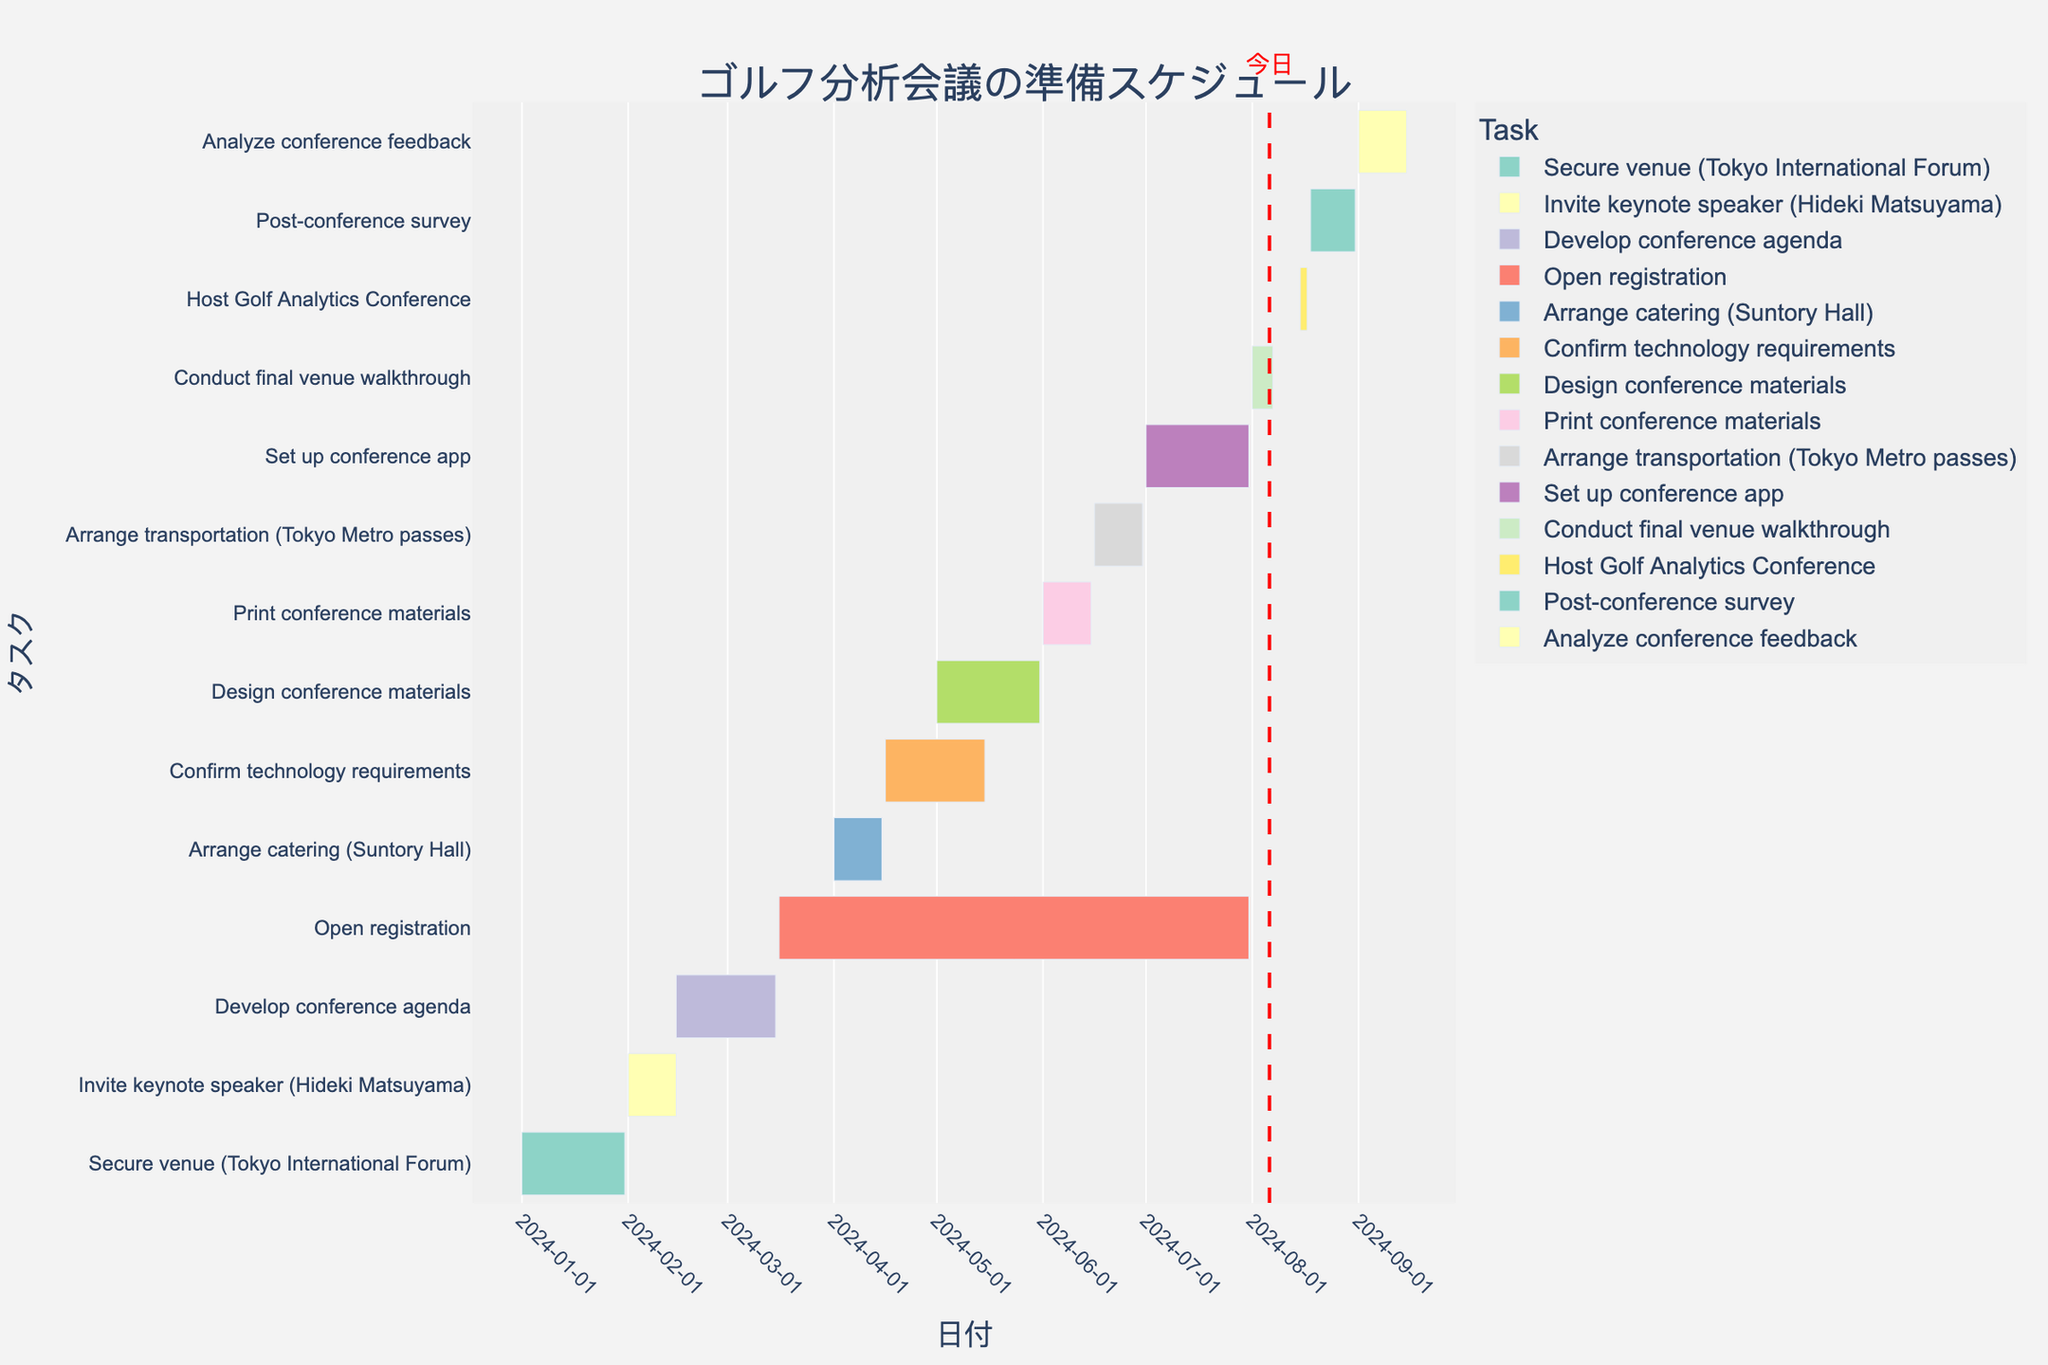What is the title of the Gantt chart? The title is usually displayed at the top of the Gantt chart. Reading the top of the chart directly reveals the title.
Answer: ゴルフ分析会議の準備スケジュール How many days is the total duration of the "Secure venue" task? The task duration is provided in the dataset. The "Secure venue" task lasts for 31 days.
Answer: 31 Which task is scheduled to occur right after "Invite keynote speaker"? The task "Develop conference agenda" starts immediately after the end date of the "Invite keynote speaker" task, which is the next task in the timeline.
Answer: Develop conference agenda During which months is the task "Open registration" scheduled? The "Open registration" task starts on March 16 and ends on July 31. Checking the timeline span gives the months March, April, May, June, and July.
Answer: March to July What is the total duration from the first to the last date in the Gantt chart? The total duration can be calculated by finding the difference between the earliest start date (2024-01-01) and the latest end date (2024-09-15).
Answer: 258 days What tasks are scheduled to start in April 2024? According to their start dates, the tasks that begin in April 2024 are "Arrange catering" and "Confirm technology requirements".
Answer: Arrange catering, Confirm technology requirements Which task has the shortest duration, and what is its duration? By looking at the duration of each task in the dataset, the task "Host Golf Analytics Conference" has the shortest duration of 3 days.
Answer: Host Golf Analytics Conference, 3 days How many tasks have a duration of 15 days? The tasks "Invite keynote speaker", "Arrange catering", "Print conference materials", "Arrange transportation", and "Analyze conference feedback" each have a duration of 15 days. There are a total of 5 such tasks.
Answer: 5 Do any tasks overlap with the "Set up conference app" task? The timeline shows that the "Set up conference app" task overlaps with the "Open registration" and "Arrange transportation" tasks.
Answer: Yes, Open registration and Arrange transportation What task immediately follows the "Conduct final venue walkthrough"? The task "Host Golf Analytics Conference" starts immediately after the end of the "Conduct final venue walkthrough" task.
Answer: Host Golf Analytics Conference 